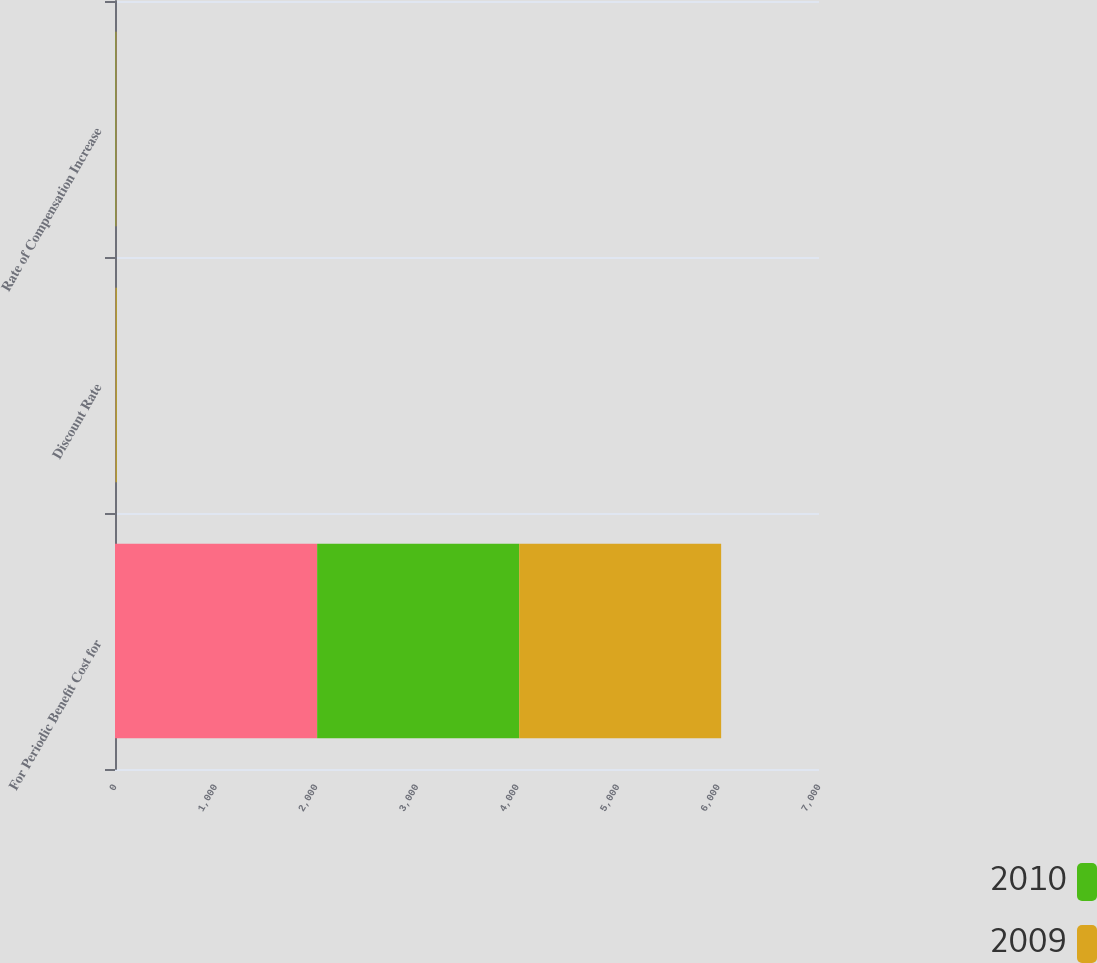Convert chart to OTSL. <chart><loc_0><loc_0><loc_500><loc_500><stacked_bar_chart><ecel><fcel>For Periodic Benefit Cost for<fcel>Discount Rate<fcel>Rate of Compensation Increase<nl><fcel>nan<fcel>2010<fcel>6.6<fcel>4.5<nl><fcel>2010<fcel>2009<fcel>6.6<fcel>4.5<nl><fcel>2009<fcel>2008<fcel>6.61<fcel>4.5<nl></chart> 